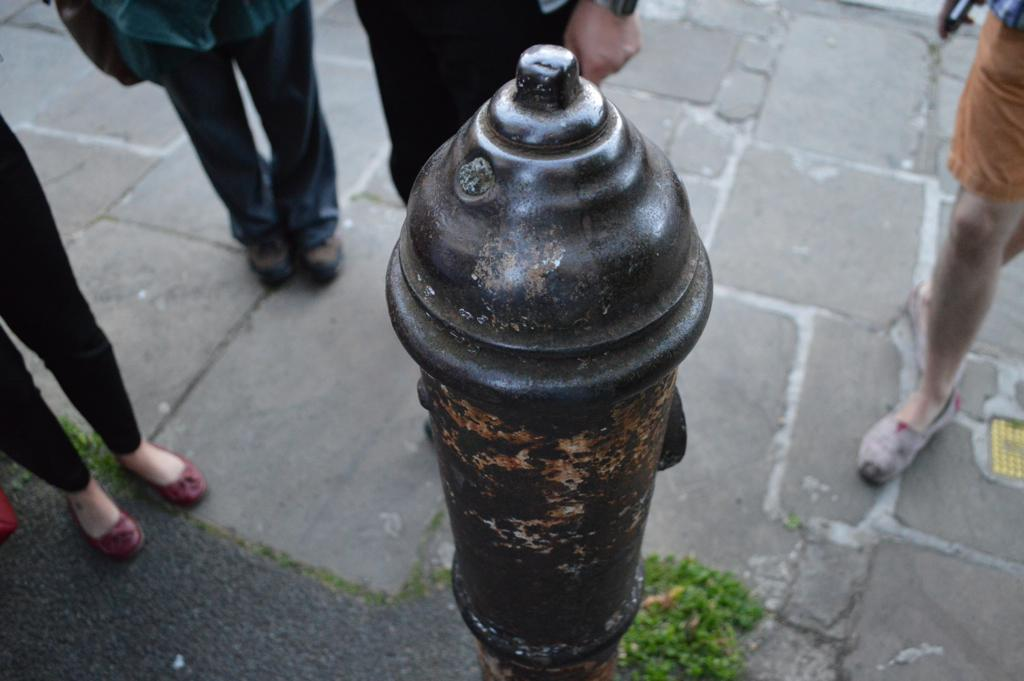What can be seen in the image that is related to water? There is a water pipe in the image. Are there any people visible in the image? Yes, there are people standing in the front of the image. What type of milk is being burned by the people in the image? There is no milk or burning activity present in the image; it only features a water pipe and people standing in front of it. 